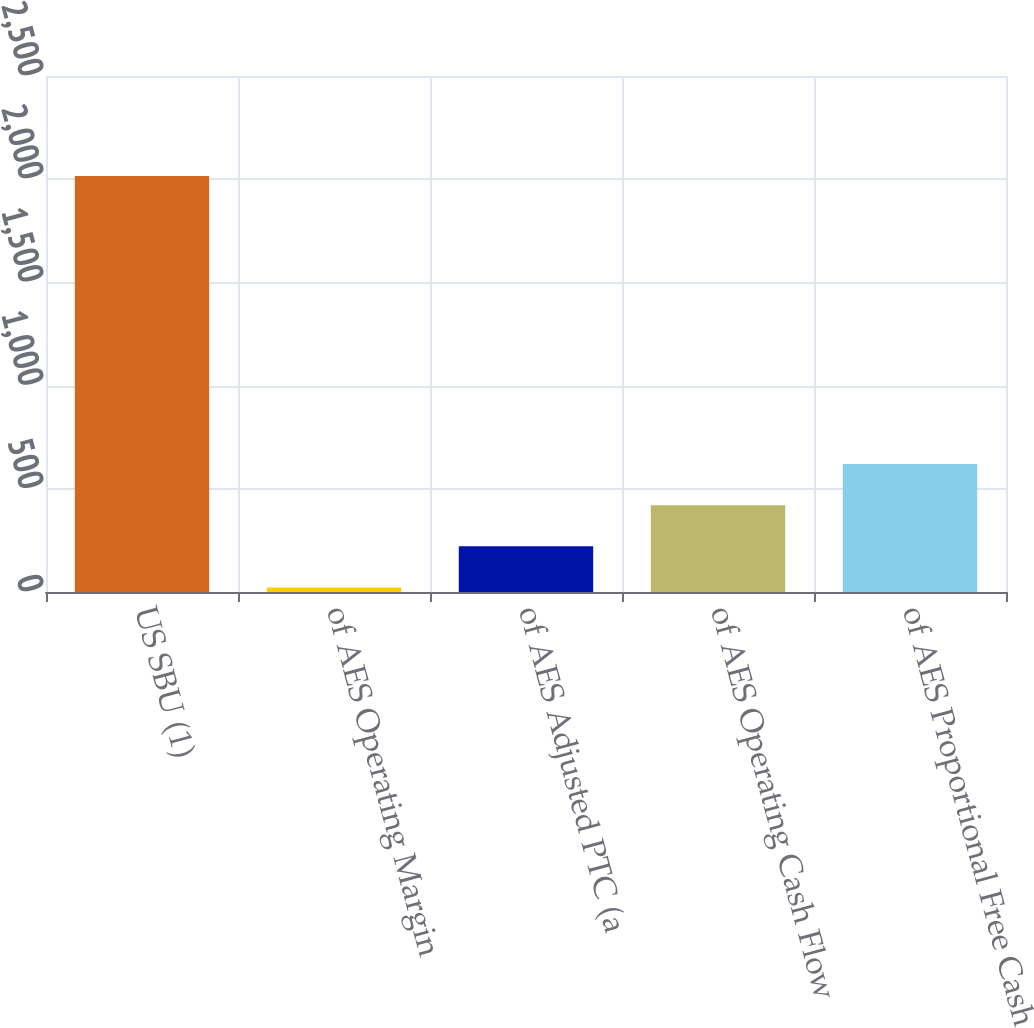Convert chart to OTSL. <chart><loc_0><loc_0><loc_500><loc_500><bar_chart><fcel>US SBU (1)<fcel>of AES Operating Margin<fcel>of AES Adjusted PTC (a<fcel>of AES Operating Cash Flow<fcel>of AES Proportional Free Cash<nl><fcel>2015<fcel>22<fcel>221.3<fcel>420.6<fcel>619.9<nl></chart> 